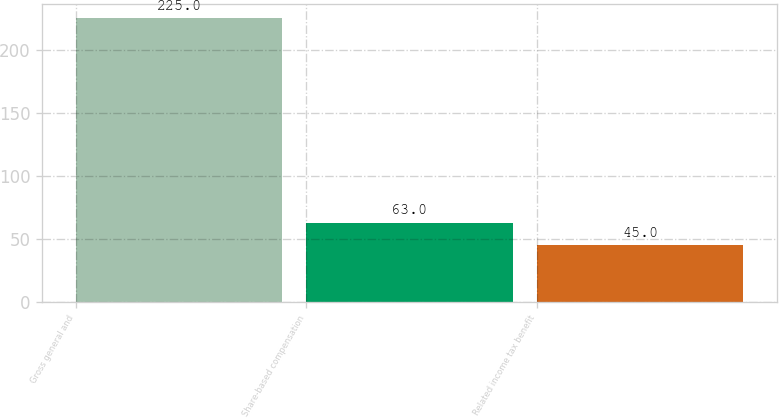Convert chart to OTSL. <chart><loc_0><loc_0><loc_500><loc_500><bar_chart><fcel>Gross general and<fcel>Share-based compensation<fcel>Related income tax benefit<nl><fcel>225<fcel>63<fcel>45<nl></chart> 